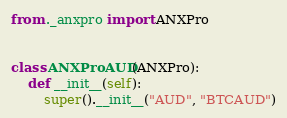<code> <loc_0><loc_0><loc_500><loc_500><_Python_>from ._anxpro import ANXPro


class ANXProAUD(ANXPro):
    def __init__(self):
        super().__init__("AUD", "BTCAUD")
</code> 